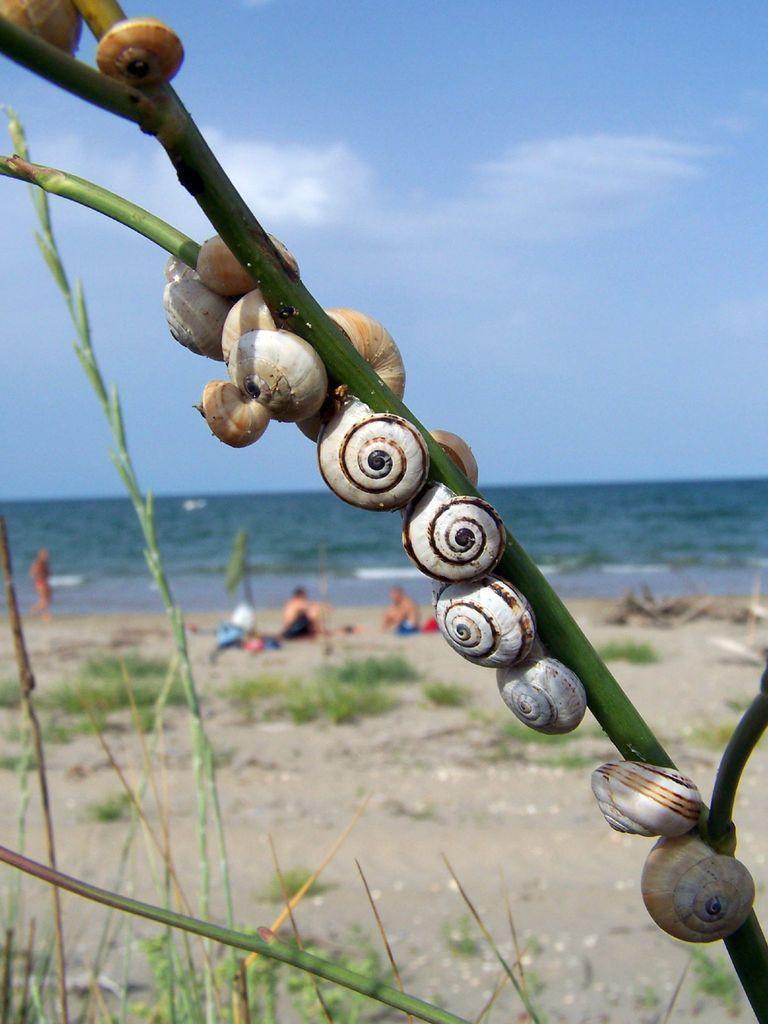In one or two sentences, can you explain what this image depicts? This picture shows about many brown and white color snails sitting on the plant branch. Behind we can see the seaside ground and three person sitting. In the background we can see clear blue sea water. 